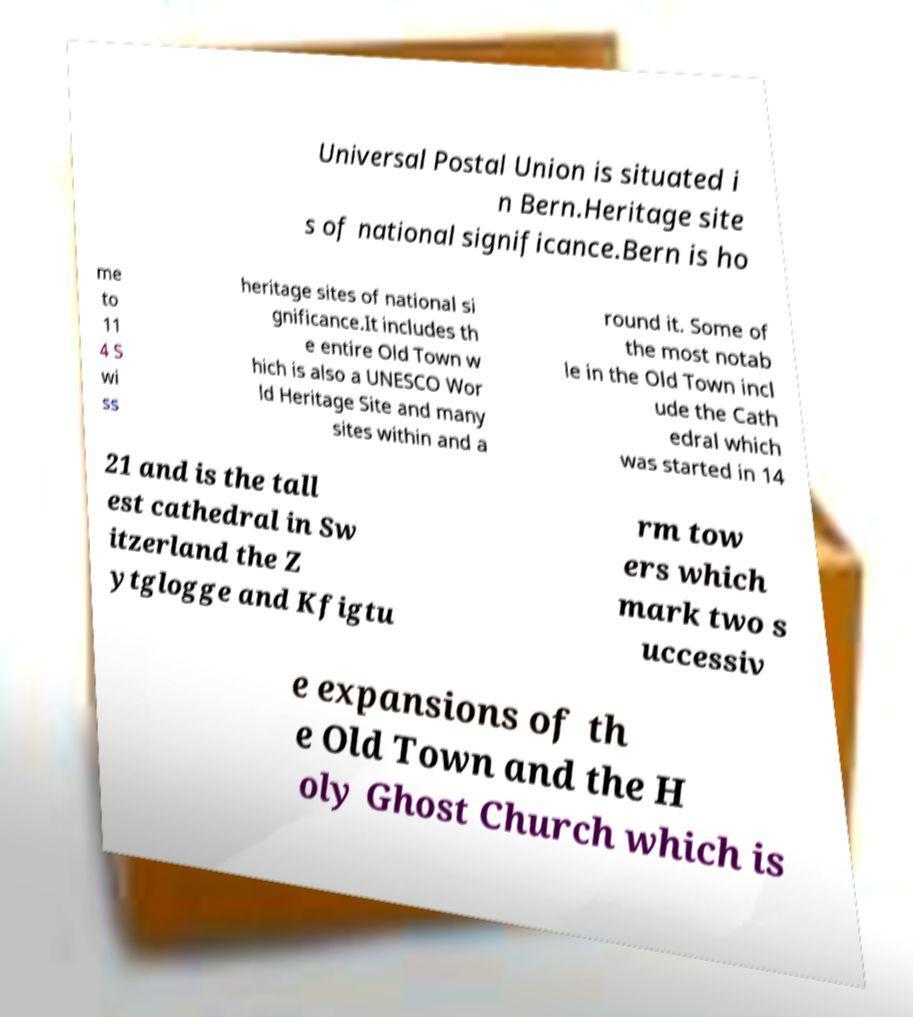Please read and relay the text visible in this image. What does it say? Universal Postal Union is situated i n Bern.Heritage site s of national significance.Bern is ho me to 11 4 S wi ss heritage sites of national si gnificance.It includes th e entire Old Town w hich is also a UNESCO Wor ld Heritage Site and many sites within and a round it. Some of the most notab le in the Old Town incl ude the Cath edral which was started in 14 21 and is the tall est cathedral in Sw itzerland the Z ytglogge and Kfigtu rm tow ers which mark two s uccessiv e expansions of th e Old Town and the H oly Ghost Church which is 